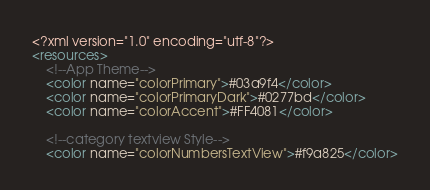Convert code to text. <code><loc_0><loc_0><loc_500><loc_500><_XML_><?xml version="1.0" encoding="utf-8"?>
<resources>
    <!--App Theme-->
    <color name="colorPrimary">#03a9f4</color>
    <color name="colorPrimaryDark">#0277bd</color>
    <color name="colorAccent">#FF4081</color>

    <!--category textview Style-->
    <color name="colorNumbersTextView">#f9a825</color></code> 